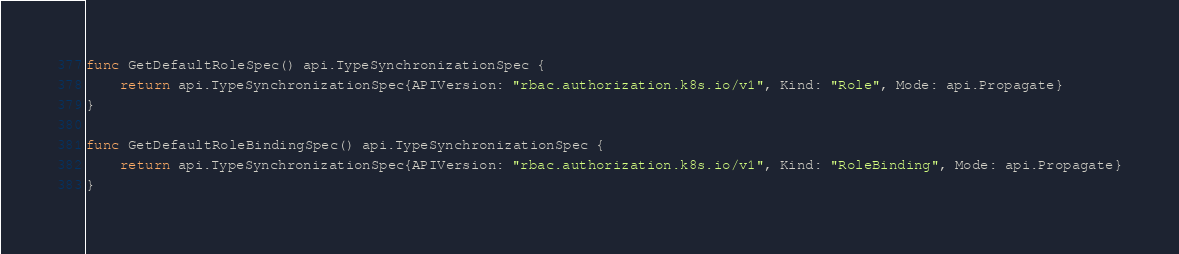<code> <loc_0><loc_0><loc_500><loc_500><_Go_>
func GetDefaultRoleSpec() api.TypeSynchronizationSpec {
	return api.TypeSynchronizationSpec{APIVersion: "rbac.authorization.k8s.io/v1", Kind: "Role", Mode: api.Propagate}
}

func GetDefaultRoleBindingSpec() api.TypeSynchronizationSpec {
	return api.TypeSynchronizationSpec{APIVersion: "rbac.authorization.k8s.io/v1", Kind: "RoleBinding", Mode: api.Propagate}
}
</code> 